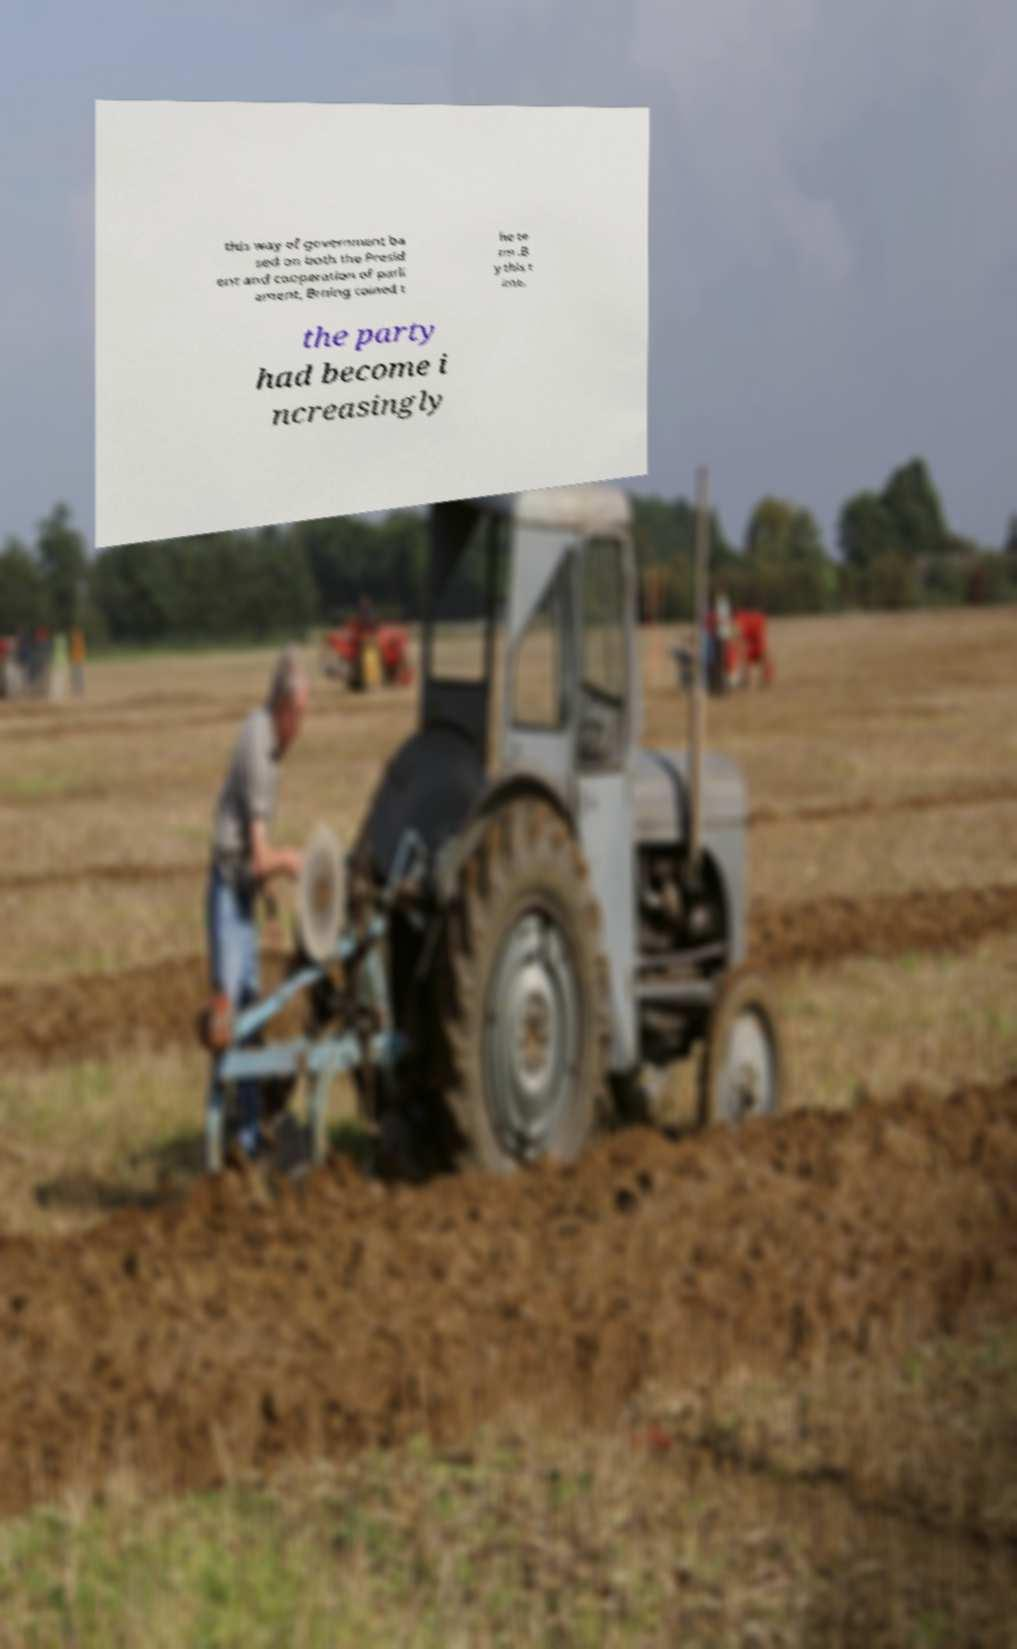I need the written content from this picture converted into text. Can you do that? this way of government ba sed on both the Presid ent and cooperation of parli ament, Brning coined t he te rm .B y this t ime, the party had become i ncreasingly 